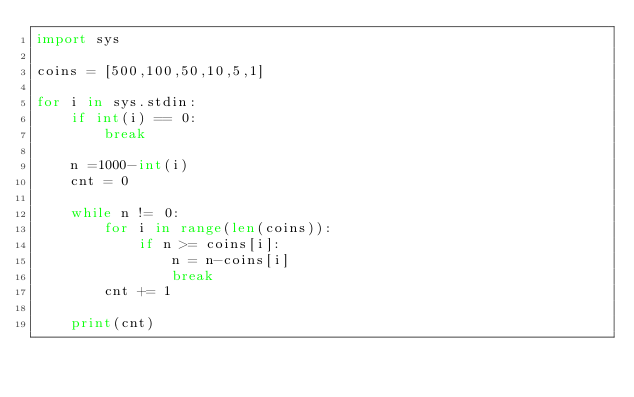Convert code to text. <code><loc_0><loc_0><loc_500><loc_500><_Python_>import sys

coins = [500,100,50,10,5,1]

for i in sys.stdin:
    if int(i) == 0:
        break

    n =1000-int(i)
    cnt = 0

    while n != 0:
        for i in range(len(coins)):
            if n >= coins[i]:
                n = n-coins[i]
                break
        cnt += 1

    print(cnt)</code> 